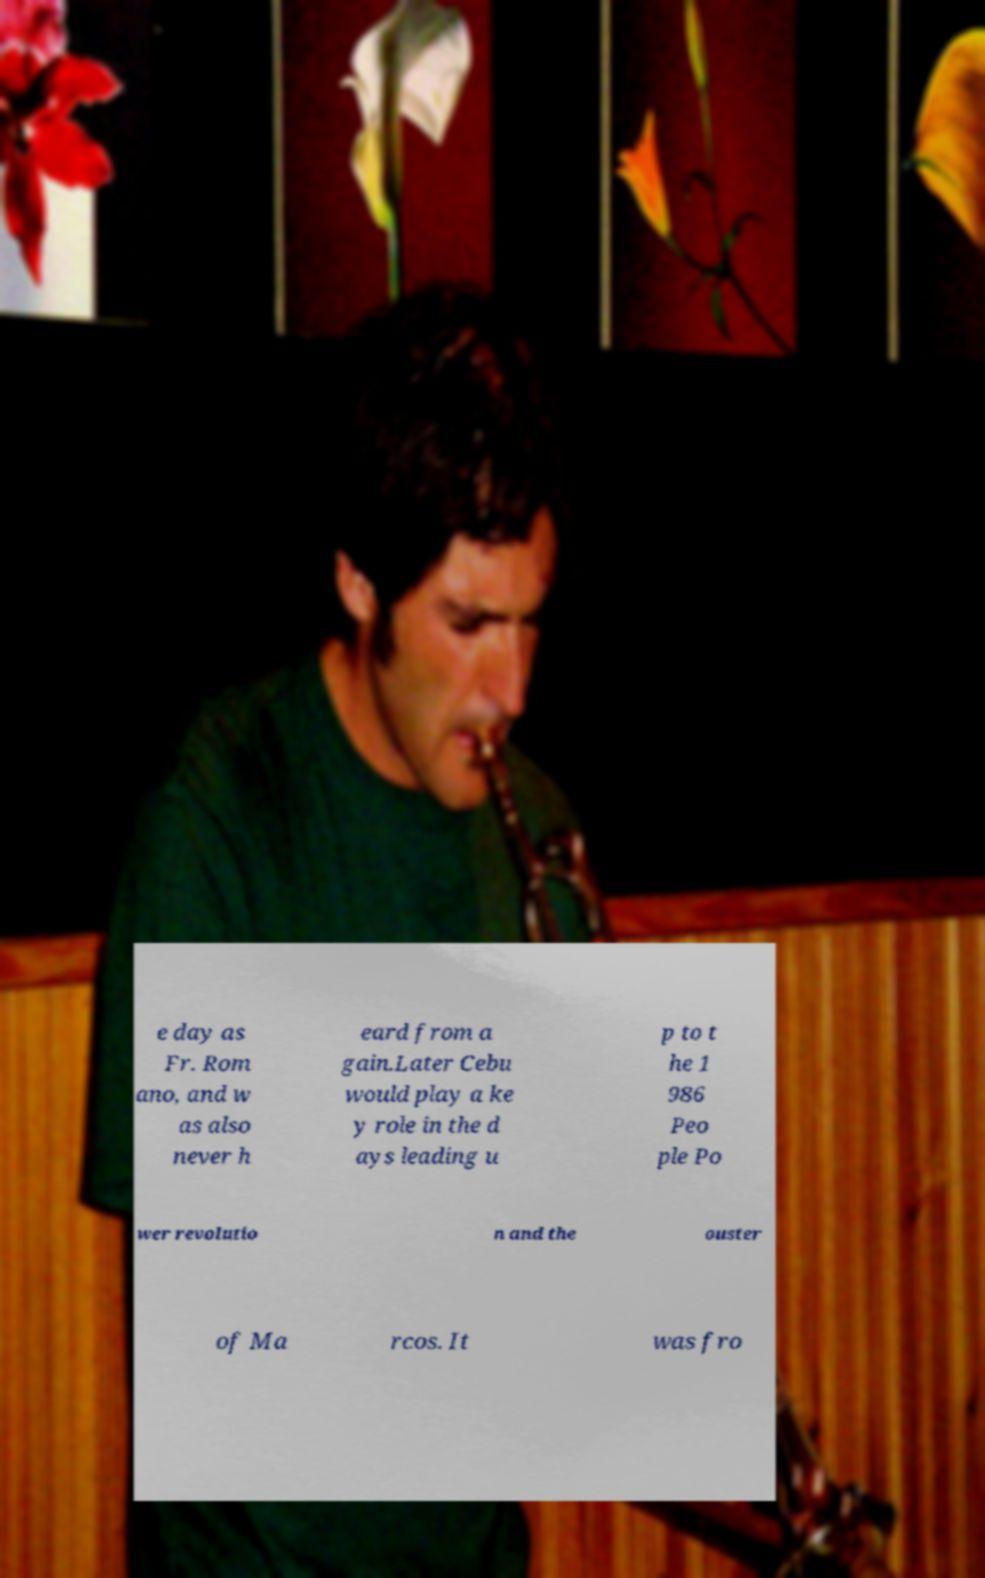Can you accurately transcribe the text from the provided image for me? e day as Fr. Rom ano, and w as also never h eard from a gain.Later Cebu would play a ke y role in the d ays leading u p to t he 1 986 Peo ple Po wer revolutio n and the ouster of Ma rcos. It was fro 